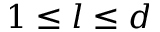<formula> <loc_0><loc_0><loc_500><loc_500>1 \leq l \leq d</formula> 